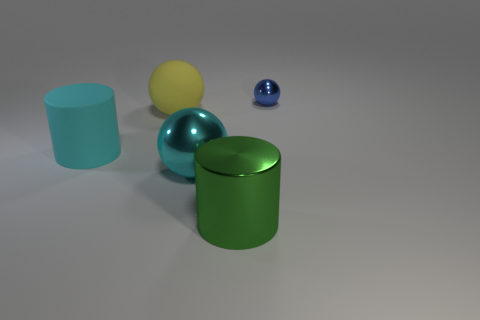What number of cyan metal things are the same size as the blue shiny thing?
Give a very brief answer. 0. The rubber cylinder that is the same color as the big metallic sphere is what size?
Offer a terse response. Large. Is there a cylinder that has the same color as the small ball?
Ensure brevity in your answer.  No. What is the color of the rubber cylinder that is the same size as the rubber sphere?
Offer a very short reply. Cyan. Is the color of the metallic cylinder the same as the large sphere in front of the cyan rubber cylinder?
Offer a very short reply. No. What is the color of the large metal ball?
Provide a short and direct response. Cyan. There is a large sphere that is behind the large cyan cylinder; what is its material?
Keep it short and to the point. Rubber. What is the size of the blue thing that is the same shape as the yellow thing?
Provide a short and direct response. Small. Is the number of cyan spheres on the right side of the green cylinder less than the number of large yellow matte balls?
Provide a short and direct response. Yes. Are any large yellow matte things visible?
Provide a succinct answer. Yes. 